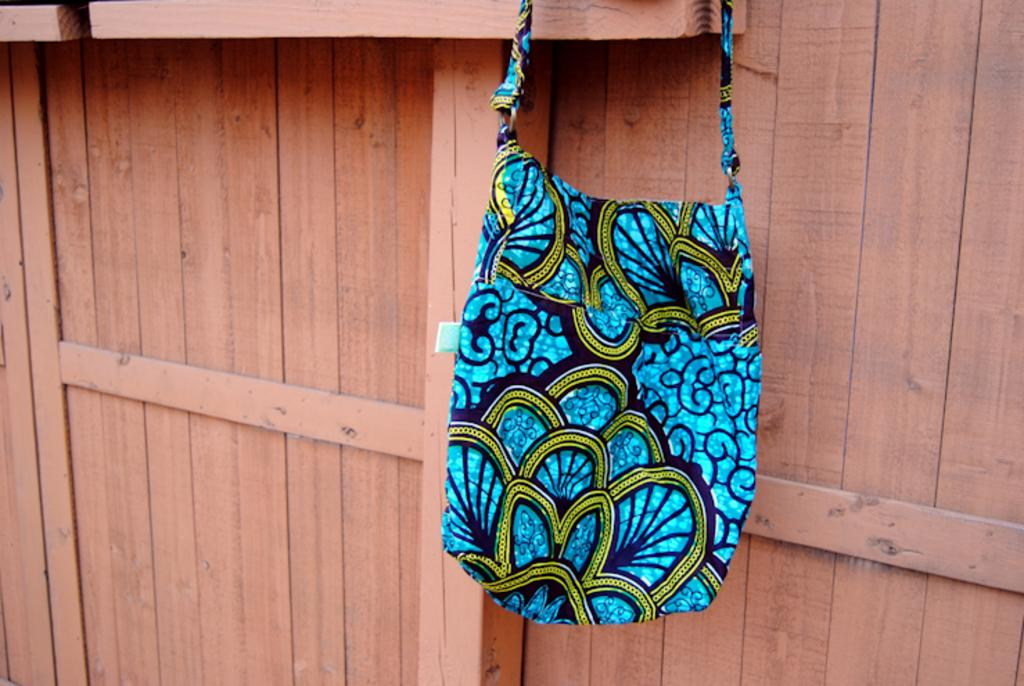What object is present in the image? There is a handbag in the image. What colors can be seen on the handbag? The handbag is in green, blue, and black colors. How is the handbag positioned in the image? The handbag is hung on a wooden-like thing. Can you observe any airplanes taking off from the airport in the image? There is no airport or airplanes present in the image; it only features a handbag hung on a wooden-like thing. 